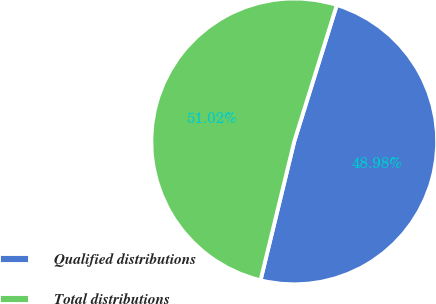<chart> <loc_0><loc_0><loc_500><loc_500><pie_chart><fcel>Qualified distributions<fcel>Total distributions<nl><fcel>48.98%<fcel>51.02%<nl></chart> 